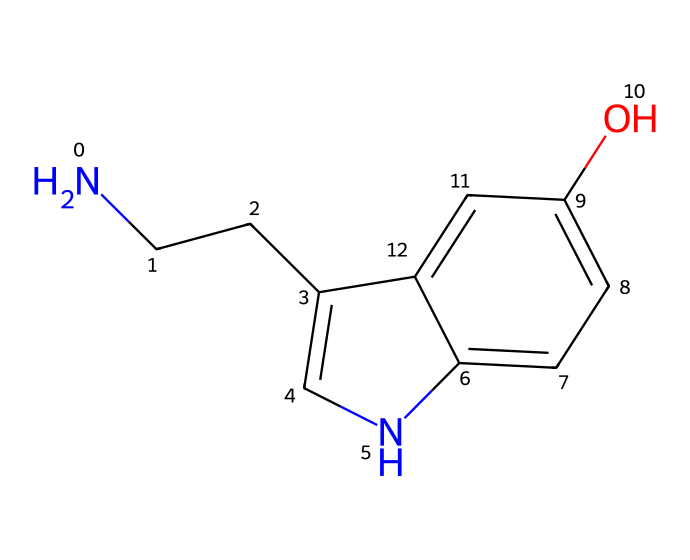How many carbon atoms are in this chemical? By analyzing the SMILES structure, the atoms represented by 'C' indicate carbon. Counting them in the structure yields a total of 8 carbon atoms.
Answer: 8 What is the total number of nitrogen atoms present? In the provided SMILES representation, 'N' indicates nitrogen. There is one 'N' in the structure, meaning it contains one nitrogen atom.
Answer: 1 Does this compound contain an -OH functional group? The presence of 'O' followed by 'H' in the structure indicates an -OH group, also known as a hydroxyl group. It is present as there is a hydroxyl (-OH) functional group in the structure.
Answer: Yes What type of bonding would you expect in this compound? The carbon and nitrogen atoms tend to form covalent bonds due to their ability to share electrons. The overall structure indicates numerous covalent bonds connecting the atoms.
Answer: Covalent Is this molecule a type of hydrocarbon? Hydrocarbons are defined as compounds composed solely of hydrogen and carbon atoms. Since this compound contains a nitrogen and an oxygen atom, it does not fit this definition fully, as it includes heteroatoms.
Answer: No What is the primary functional group found in this compound? By examining the structure, the primary functional group is the hydroxyl group (-OH), as it plays a crucial role in modifying the chemical's reactivity and properties.
Answer: Hydroxyl What role does the nitrogen atom play in this molecule? The nitrogen atom serves as part of an amine group, which is known for impacting the molecule’s properties as a neurotransmitter, adding polarity and enabling hydrogen bonding.
Answer: Amine 